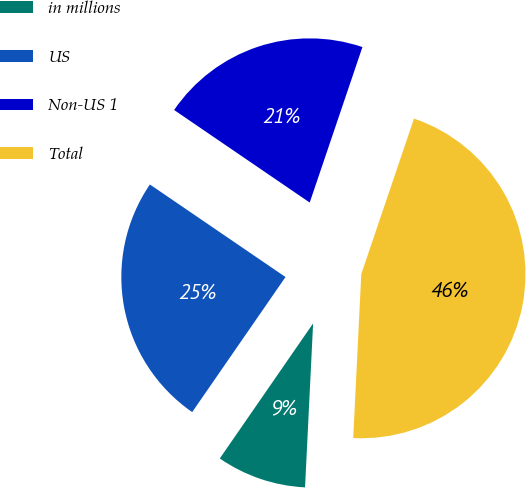Convert chart to OTSL. <chart><loc_0><loc_0><loc_500><loc_500><pie_chart><fcel>in millions<fcel>US<fcel>Non-US 1<fcel>Total<nl><fcel>8.84%<fcel>24.91%<fcel>20.67%<fcel>45.58%<nl></chart> 